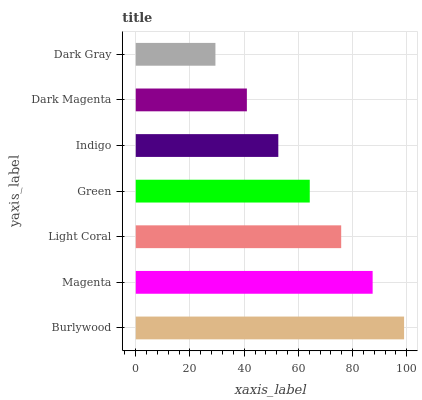Is Dark Gray the minimum?
Answer yes or no. Yes. Is Burlywood the maximum?
Answer yes or no. Yes. Is Magenta the minimum?
Answer yes or no. No. Is Magenta the maximum?
Answer yes or no. No. Is Burlywood greater than Magenta?
Answer yes or no. Yes. Is Magenta less than Burlywood?
Answer yes or no. Yes. Is Magenta greater than Burlywood?
Answer yes or no. No. Is Burlywood less than Magenta?
Answer yes or no. No. Is Green the high median?
Answer yes or no. Yes. Is Green the low median?
Answer yes or no. Yes. Is Dark Magenta the high median?
Answer yes or no. No. Is Indigo the low median?
Answer yes or no. No. 